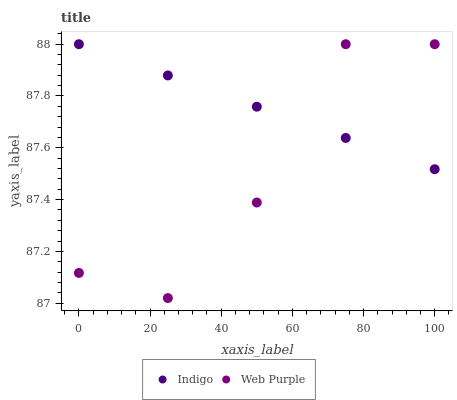Does Web Purple have the minimum area under the curve?
Answer yes or no. Yes. Does Indigo have the maximum area under the curve?
Answer yes or no. Yes. Does Indigo have the minimum area under the curve?
Answer yes or no. No. Is Indigo the smoothest?
Answer yes or no. Yes. Is Web Purple the roughest?
Answer yes or no. Yes. Is Indigo the roughest?
Answer yes or no. No. Does Web Purple have the lowest value?
Answer yes or no. Yes. Does Indigo have the lowest value?
Answer yes or no. No. Does Indigo have the highest value?
Answer yes or no. Yes. Does Indigo intersect Web Purple?
Answer yes or no. Yes. Is Indigo less than Web Purple?
Answer yes or no. No. Is Indigo greater than Web Purple?
Answer yes or no. No. 